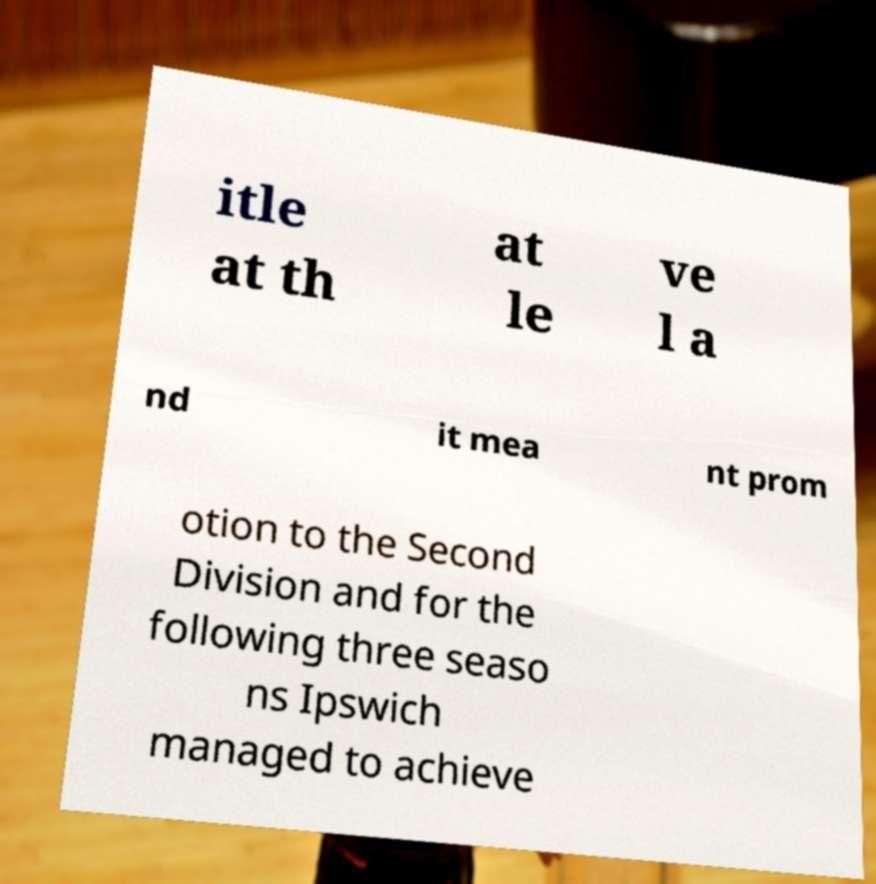There's text embedded in this image that I need extracted. Can you transcribe it verbatim? itle at th at le ve l a nd it mea nt prom otion to the Second Division and for the following three seaso ns Ipswich managed to achieve 